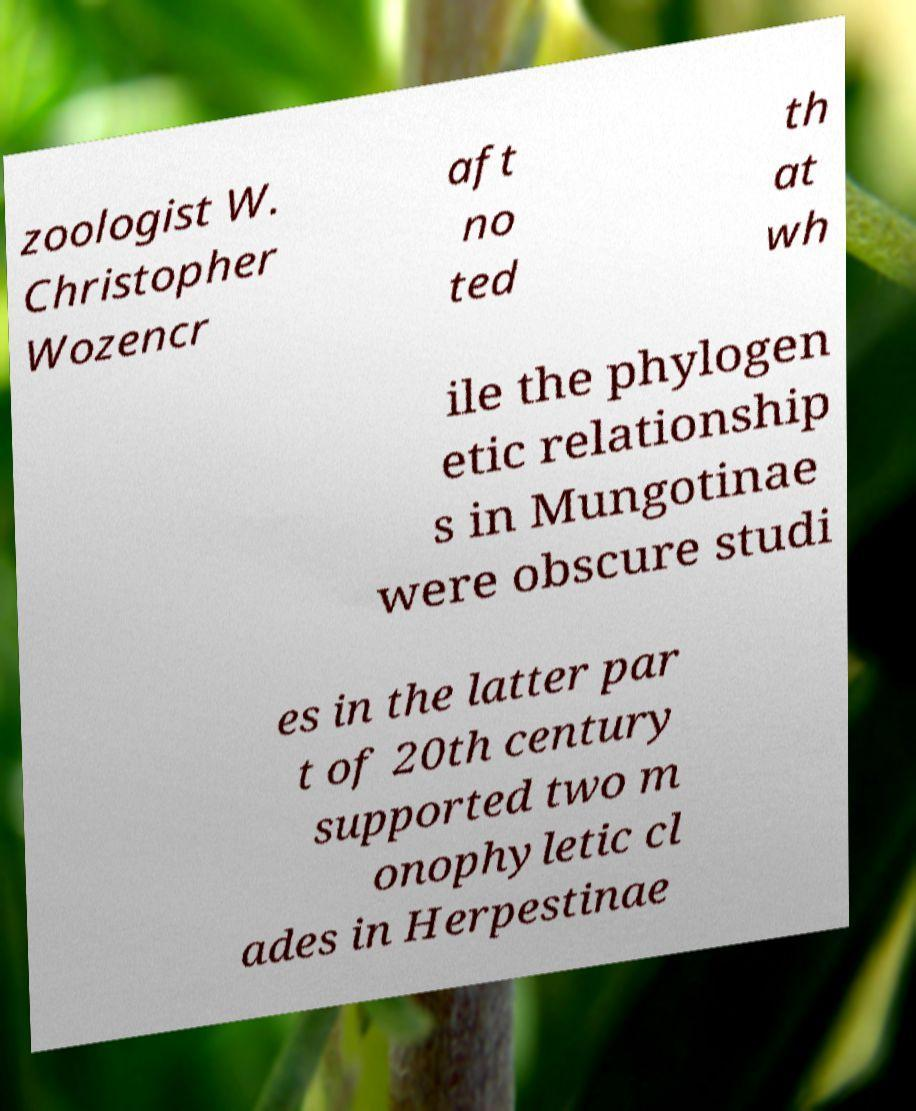I need the written content from this picture converted into text. Can you do that? zoologist W. Christopher Wozencr aft no ted th at wh ile the phylogen etic relationship s in Mungotinae were obscure studi es in the latter par t of 20th century supported two m onophyletic cl ades in Herpestinae 